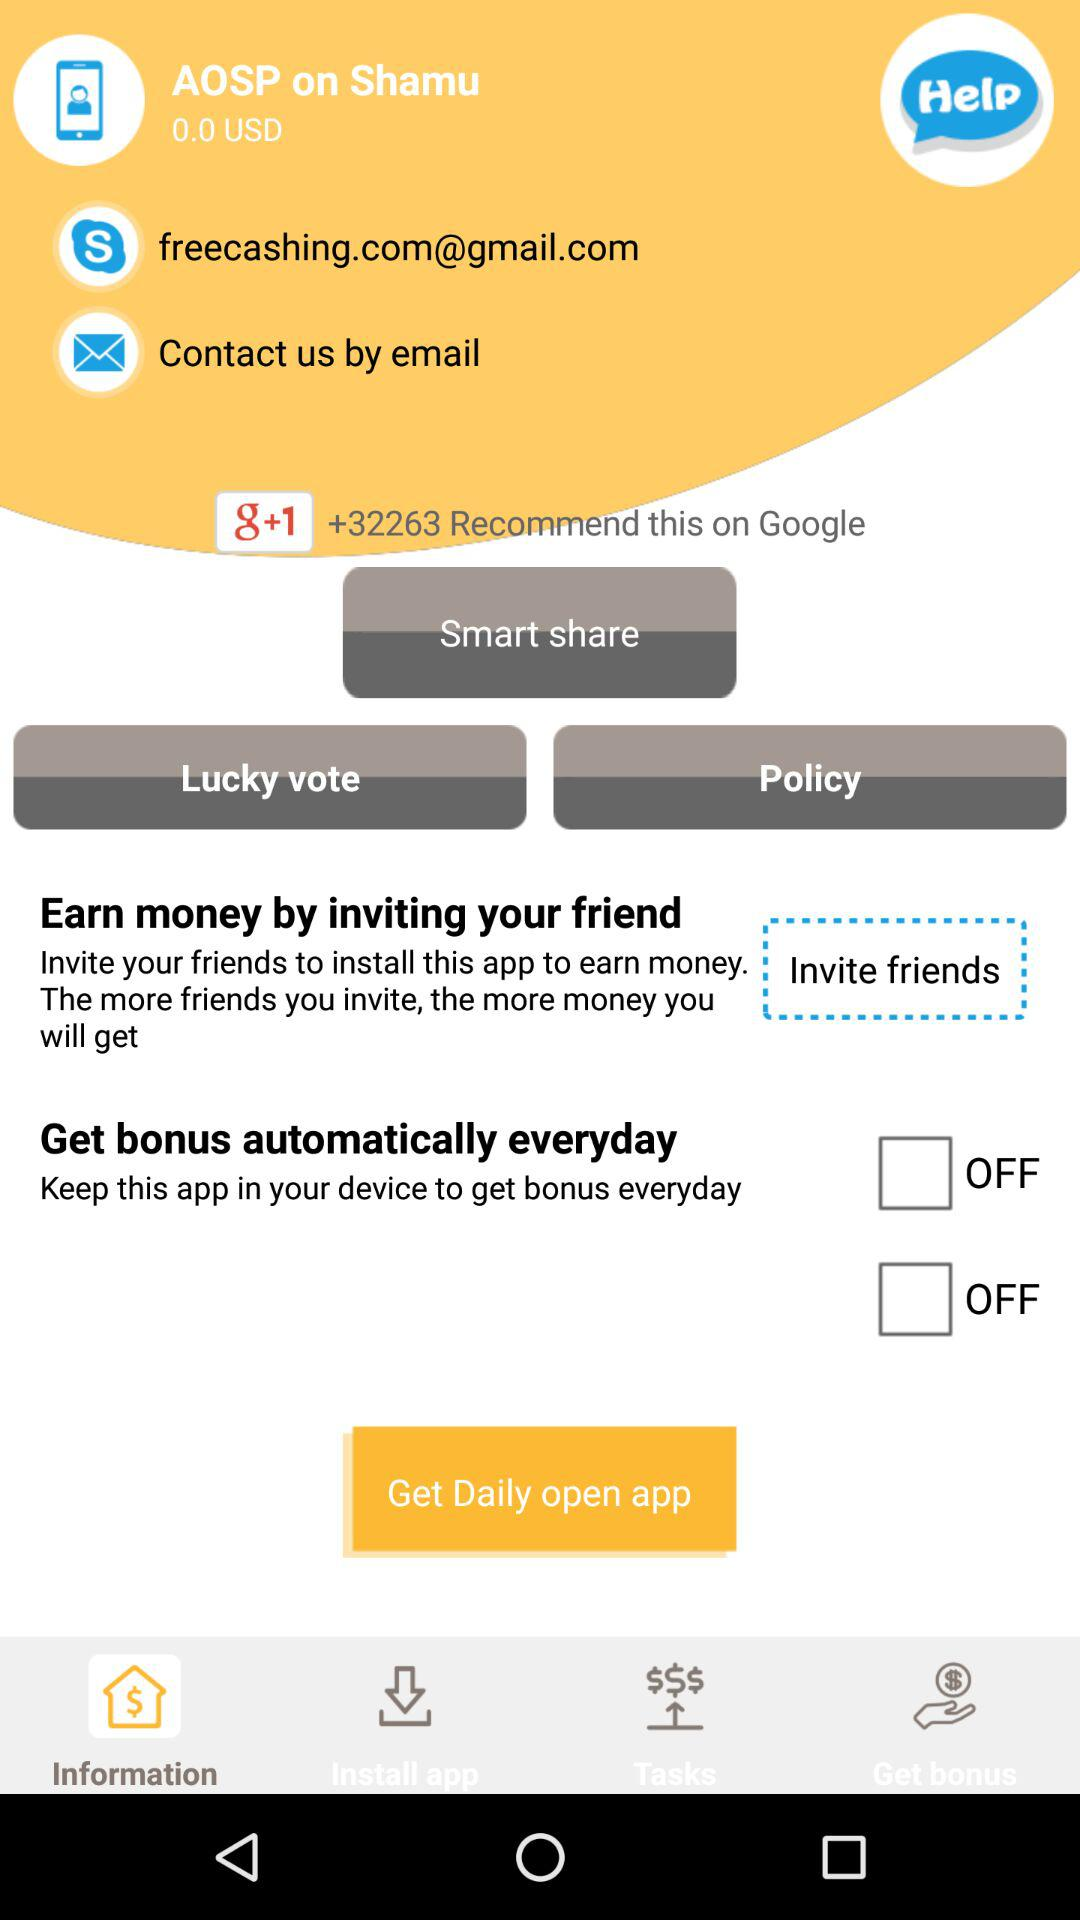How many people recommend "g+1" on Google? On Google, more than 32263 people recommend "g+1". 